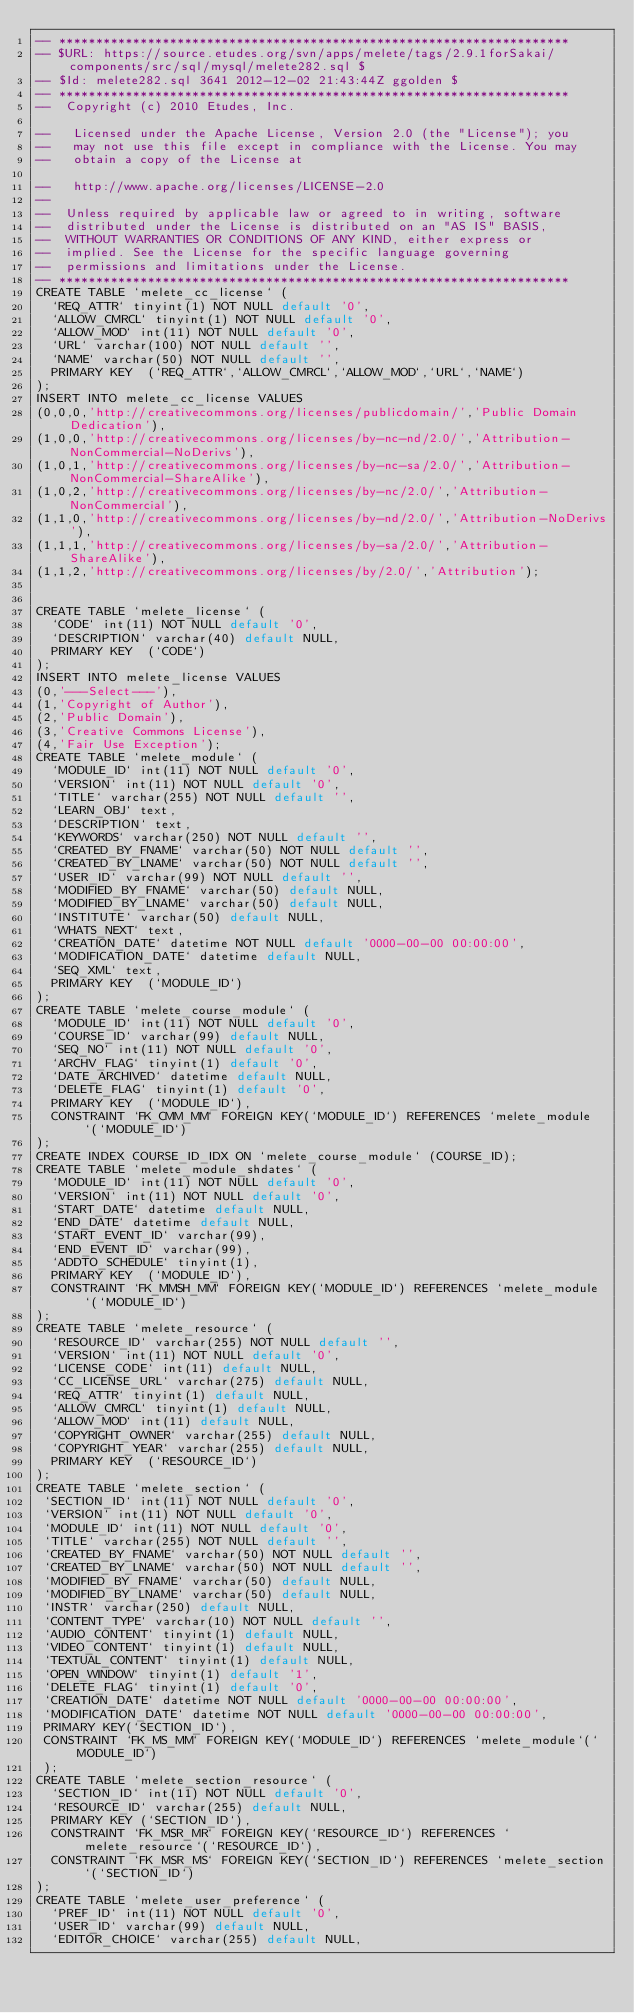<code> <loc_0><loc_0><loc_500><loc_500><_SQL_>-- *********************************************************************
-- $URL: https://source.etudes.org/svn/apps/melete/tags/2.9.1forSakai/components/src/sql/mysql/melete282.sql $
-- $Id: melete282.sql 3641 2012-12-02 21:43:44Z ggolden $
-- *********************************************************************
--  Copyright (c) 2010 Etudes, Inc.  
  
--   Licensed under the Apache License, Version 2.0 (the "License"); you  
--   may not use this file except in compliance with the License. You may  
--   obtain a copy of the License at  
  
--   http://www.apache.org/licenses/LICENSE-2.0  
--
--  Unless required by applicable law or agreed to in writing, software  
--  distributed under the License is distributed on an "AS IS" BASIS,  
--  WITHOUT WARRANTIES OR CONDITIONS OF ANY KIND, either express or  
--  implied. See the License for the specific language governing  
--  permissions and limitations under the License. 
-- ********************************************************************* 
CREATE TABLE `melete_cc_license` (
  `REQ_ATTR` tinyint(1) NOT NULL default '0',
  `ALLOW_CMRCL` tinyint(1) NOT NULL default '0',
  `ALLOW_MOD` int(11) NOT NULL default '0',
  `URL` varchar(100) NOT NULL default '',
  `NAME` varchar(50) NOT NULL default '',
  PRIMARY KEY  (`REQ_ATTR`,`ALLOW_CMRCL`,`ALLOW_MOD`,`URL`,`NAME`)
);
INSERT INTO melete_cc_license VALUES 
(0,0,0,'http://creativecommons.org/licenses/publicdomain/','Public Domain Dedication'),
(1,0,0,'http://creativecommons.org/licenses/by-nc-nd/2.0/','Attribution-NonCommercial-NoDerivs'),
(1,0,1,'http://creativecommons.org/licenses/by-nc-sa/2.0/','Attribution-NonCommercial-ShareAlike'),
(1,0,2,'http://creativecommons.org/licenses/by-nc/2.0/','Attribution-NonCommercial'),
(1,1,0,'http://creativecommons.org/licenses/by-nd/2.0/','Attribution-NoDerivs'),
(1,1,1,'http://creativecommons.org/licenses/by-sa/2.0/','Attribution-ShareAlike'),
(1,1,2,'http://creativecommons.org/licenses/by/2.0/','Attribution');


CREATE TABLE `melete_license` (
  `CODE` int(11) NOT NULL default '0',
  `DESCRIPTION` varchar(40) default NULL,
  PRIMARY KEY  (`CODE`)
);
INSERT INTO melete_license VALUES 
(0,'---Select---'),
(1,'Copyright of Author'),
(2,'Public Domain'),
(3,'Creative Commons License'),
(4,'Fair Use Exception');
CREATE TABLE `melete_module` (
  `MODULE_ID` int(11) NOT NULL default '0',
  `VERSION` int(11) NOT NULL default '0',
  `TITLE` varchar(255) NOT NULL default '',
  `LEARN_OBJ` text,
  `DESCRIPTION` text,
  `KEYWORDS` varchar(250) NOT NULL default '',
  `CREATED_BY_FNAME` varchar(50) NOT NULL default '',
  `CREATED_BY_LNAME` varchar(50) NOT NULL default '',
  `USER_ID` varchar(99) NOT NULL default '',
  `MODIFIED_BY_FNAME` varchar(50) default NULL,
  `MODIFIED_BY_LNAME` varchar(50) default NULL,
  `INSTITUTE` varchar(50) default NULL,
  `WHATS_NEXT` text,
  `CREATION_DATE` datetime NOT NULL default '0000-00-00 00:00:00',
  `MODIFICATION_DATE` datetime default NULL,
  `SEQ_XML` text,
  PRIMARY KEY  (`MODULE_ID`)
);
CREATE TABLE `melete_course_module` (
  `MODULE_ID` int(11) NOT NULL default '0',
  `COURSE_ID` varchar(99) default NULL,
  `SEQ_NO` int(11) NOT NULL default '0',
  `ARCHV_FLAG` tinyint(1) default '0',
  `DATE_ARCHIVED` datetime default NULL,
  `DELETE_FLAG` tinyint(1) default '0',
  PRIMARY KEY  (`MODULE_ID`),
  CONSTRAINT `FK_CMM_MM` FOREIGN KEY(`MODULE_ID`) REFERENCES `melete_module`(`MODULE_ID`)
);
CREATE INDEX COURSE_ID_IDX ON `melete_course_module` (COURSE_ID); 
CREATE TABLE `melete_module_shdates` (
  `MODULE_ID` int(11) NOT NULL default '0',
  `VERSION` int(11) NOT NULL default '0',
  `START_DATE` datetime default NULL,
  `END_DATE` datetime default NULL,
  `START_EVENT_ID` varchar(99),
  `END_EVENT_ID` varchar(99),
  `ADDTO_SCHEDULE` tinyint(1),
  PRIMARY KEY  (`MODULE_ID`),
  CONSTRAINT `FK_MMSH_MM` FOREIGN KEY(`MODULE_ID`) REFERENCES `melete_module`(`MODULE_ID`)
);
CREATE TABLE `melete_resource` (
  `RESOURCE_ID` varchar(255) NOT NULL default '',
  `VERSION` int(11) NOT NULL default '0',
  `LICENSE_CODE` int(11) default NULL,
  `CC_LICENSE_URL` varchar(275) default NULL,
  `REQ_ATTR` tinyint(1) default NULL,
  `ALLOW_CMRCL` tinyint(1) default NULL,
  `ALLOW_MOD` int(11) default NULL,
  `COPYRIGHT_OWNER` varchar(255) default NULL,
  `COPYRIGHT_YEAR` varchar(255) default NULL,
  PRIMARY KEY  (`RESOURCE_ID`)
);
CREATE TABLE `melete_section` (
 `SECTION_ID` int(11) NOT NULL default '0',
 `VERSION` int(11) NOT NULL default '0',
 `MODULE_ID` int(11) NOT NULL default '0',
 `TITLE` varchar(255) NOT NULL default '',
 `CREATED_BY_FNAME` varchar(50) NOT NULL default '',
 `CREATED_BY_LNAME` varchar(50) NOT NULL default '',
 `MODIFIED_BY_FNAME` varchar(50) default NULL,
 `MODIFIED_BY_LNAME` varchar(50) default NULL,
 `INSTR` varchar(250) default NULL,
 `CONTENT_TYPE` varchar(10) NOT NULL default '',
 `AUDIO_CONTENT` tinyint(1) default NULL,
 `VIDEO_CONTENT` tinyint(1) default NULL,
 `TEXTUAL_CONTENT` tinyint(1) default NULL,
 `OPEN_WINDOW` tinyint(1) default '1',
 `DELETE_FLAG` tinyint(1) default '0',
 `CREATION_DATE` datetime NOT NULL default '0000-00-00 00:00:00',
 `MODIFICATION_DATE` datetime NOT NULL default '0000-00-00 00:00:00',
 PRIMARY KEY(`SECTION_ID`),
 CONSTRAINT `FK_MS_MM` FOREIGN KEY(`MODULE_ID`) REFERENCES `melete_module`(`MODULE_ID`)
 );
CREATE TABLE `melete_section_resource` (
  `SECTION_ID` int(11) NOT NULL default '0',
  `RESOURCE_ID` varchar(255) default NULL,
  PRIMARY KEY (`SECTION_ID`),
  CONSTRAINT `FK_MSR_MR` FOREIGN KEY(`RESOURCE_ID`) REFERENCES `melete_resource`(`RESOURCE_ID`),
  CONSTRAINT `FK_MSR_MS` FOREIGN KEY(`SECTION_ID`) REFERENCES `melete_section`(`SECTION_ID`)
);
CREATE TABLE `melete_user_preference` (
  `PREF_ID` int(11) NOT NULL default '0',
  `USER_ID` varchar(99) default NULL,
  `EDITOR_CHOICE` varchar(255) default NULL,</code> 